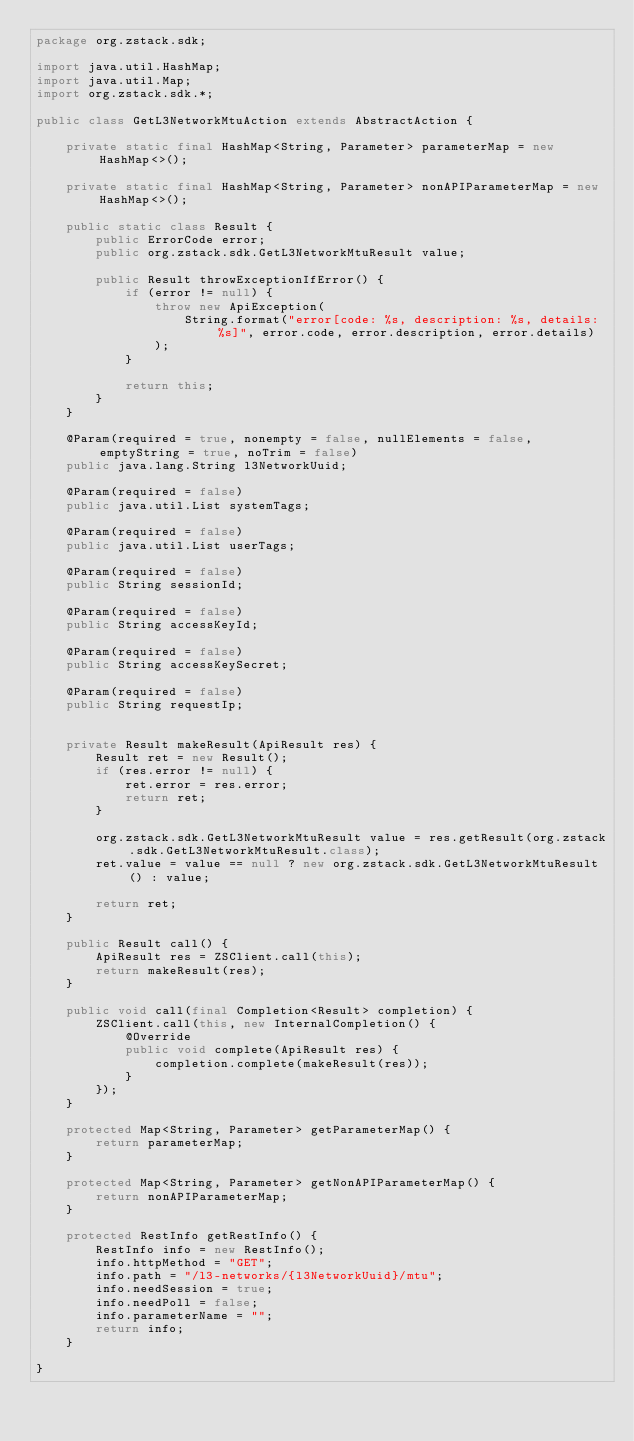<code> <loc_0><loc_0><loc_500><loc_500><_Java_>package org.zstack.sdk;

import java.util.HashMap;
import java.util.Map;
import org.zstack.sdk.*;

public class GetL3NetworkMtuAction extends AbstractAction {

    private static final HashMap<String, Parameter> parameterMap = new HashMap<>();

    private static final HashMap<String, Parameter> nonAPIParameterMap = new HashMap<>();

    public static class Result {
        public ErrorCode error;
        public org.zstack.sdk.GetL3NetworkMtuResult value;

        public Result throwExceptionIfError() {
            if (error != null) {
                throw new ApiException(
                    String.format("error[code: %s, description: %s, details: %s]", error.code, error.description, error.details)
                );
            }
            
            return this;
        }
    }

    @Param(required = true, nonempty = false, nullElements = false, emptyString = true, noTrim = false)
    public java.lang.String l3NetworkUuid;

    @Param(required = false)
    public java.util.List systemTags;

    @Param(required = false)
    public java.util.List userTags;

    @Param(required = false)
    public String sessionId;

    @Param(required = false)
    public String accessKeyId;

    @Param(required = false)
    public String accessKeySecret;

    @Param(required = false)
    public String requestIp;


    private Result makeResult(ApiResult res) {
        Result ret = new Result();
        if (res.error != null) {
            ret.error = res.error;
            return ret;
        }
        
        org.zstack.sdk.GetL3NetworkMtuResult value = res.getResult(org.zstack.sdk.GetL3NetworkMtuResult.class);
        ret.value = value == null ? new org.zstack.sdk.GetL3NetworkMtuResult() : value; 

        return ret;
    }

    public Result call() {
        ApiResult res = ZSClient.call(this);
        return makeResult(res);
    }

    public void call(final Completion<Result> completion) {
        ZSClient.call(this, new InternalCompletion() {
            @Override
            public void complete(ApiResult res) {
                completion.complete(makeResult(res));
            }
        });
    }

    protected Map<String, Parameter> getParameterMap() {
        return parameterMap;
    }

    protected Map<String, Parameter> getNonAPIParameterMap() {
        return nonAPIParameterMap;
    }

    protected RestInfo getRestInfo() {
        RestInfo info = new RestInfo();
        info.httpMethod = "GET";
        info.path = "/l3-networks/{l3NetworkUuid}/mtu";
        info.needSession = true;
        info.needPoll = false;
        info.parameterName = "";
        return info;
    }

}
</code> 